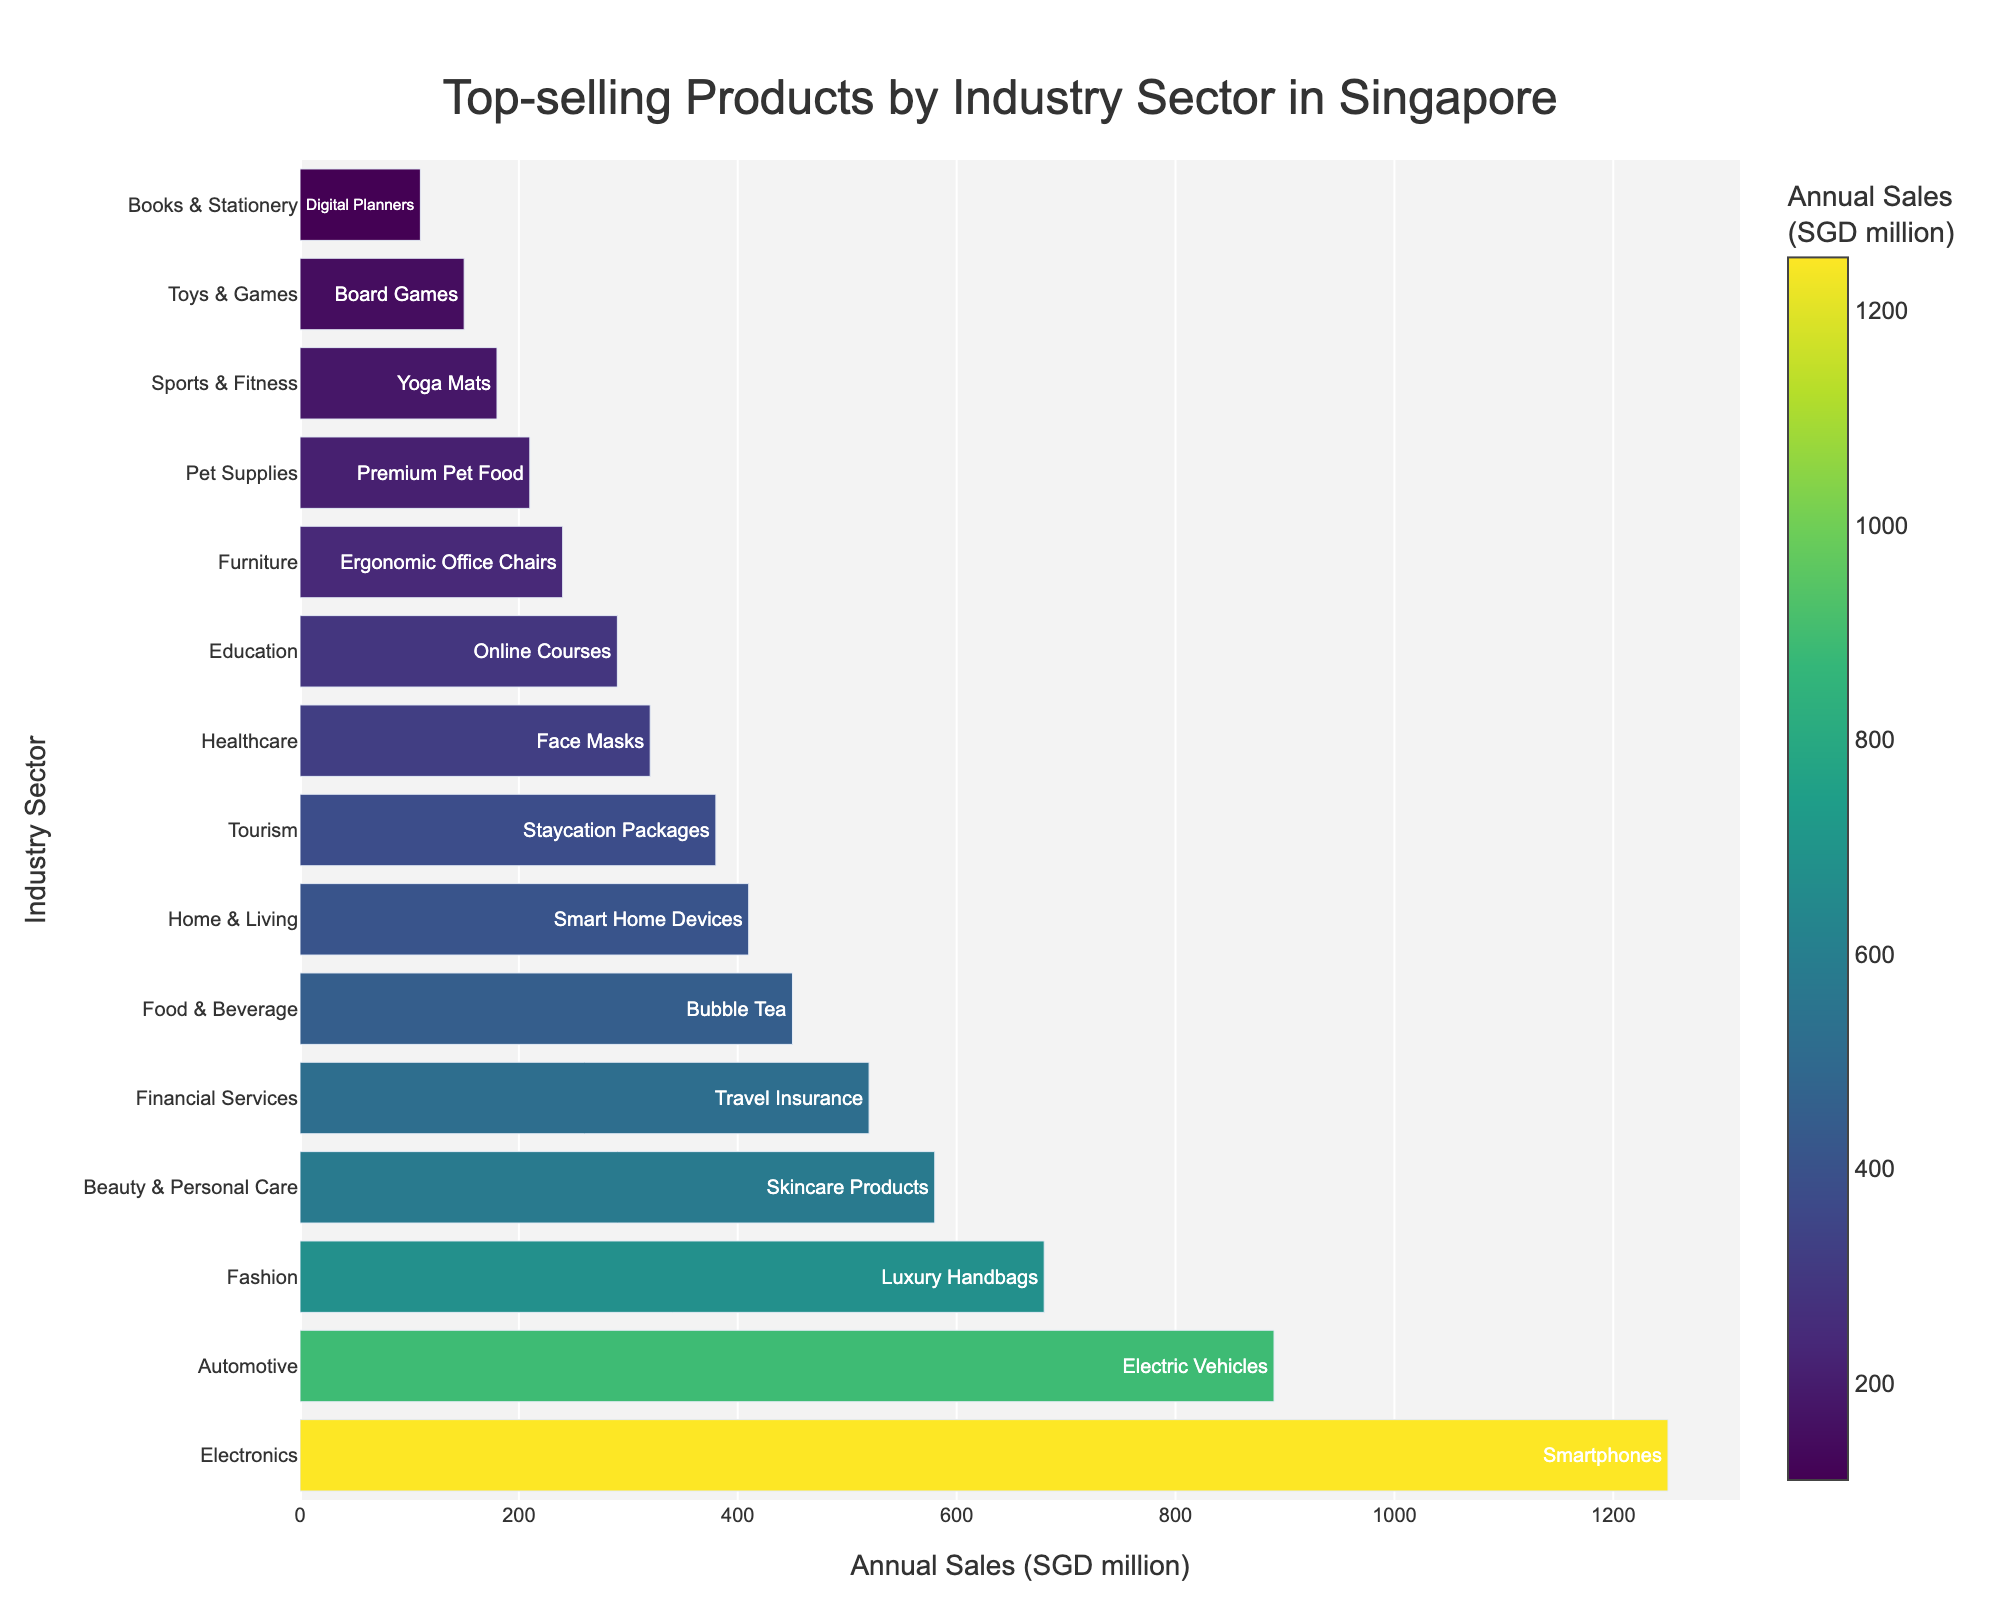What is the industry sector with the highest annual sales? The industry sector with the highest annual sales can be identified by looking for the tallest bar on the plot. The tallest bar belongs to the Electronics sector.
Answer: Electronics Which industry sector has the lowest annual sales, and what is its top-selling product? To find the industry sector with the lowest annual sales, look for the shortest bar in the plot. The shortest bar belongs to the Books & Stationery sector, and its top-selling product is Digital Planners.
Answer: Books & Stationery Which two industry sectors have annual sales of over 1,000 million SGD? To find industry sectors with annual sales over 1,000 million SGD, identify the bars that extend past the 1,000 million mark on the x-axis. The two sectors are Electronics and Automotive.
Answer: Electronics, Automotive What is the difference in annual sales between the Healthcare and Tourism sectors? To find the difference in annual sales, locate the positions of the bars for Healthcare and Tourism. Healthcare has 320 million SGD, and Tourism has 380 million SGD. The difference is 380 - 320 = 60 million SGD.
Answer: 60 million SGD What are the top-selling products for the top 3 industry sectors? To determine the top 3 industry sectors, look at the three tallest bars in the plot. They are Electronics (Smartphones), Automotive (Electric Vehicles), and Fashion (Luxury Handbags).
Answer: Smartphones, Electric Vehicles, Luxury Handbags Which industry sector has annual sales closest to 300 million SGD? To find the industry sector with annual sales closest to 300 million SGD, locate the bars near the 300 million mark. The Healthcare sector has annual sales of 320 million SGD, which is closest to 300 million.
Answer: Healthcare What is the combined annual sales of the Financial Services and Tourism sectors? To find the combined annual sales, add the values of the bars for Financial Services (520 million SGD) and Tourism (380 million SGD). The combined total is 520 + 380 = 900 million SGD.
Answer: 900 million SGD How does the annual sales of Smart Home Devices compare to Face Masks? To compare the annual sales, observe the bars for the Home & Living sector (Smart Home Devices) and Healthcare sector (Face Masks). Smart Home Devices have 410 million SGD, while Face Masks have 320 million SGD. Smart Home Devices have higher sales.
Answer: Smart Home Devices have higher sales What color represents the Skincare Products bar on the color scale? Identify the color of the bar for the Beauty & Personal Care sector, which sells Skincare Products. The color scale ranges from light to dark green. The Skincare Products bar is represented by a medium shade of green.
Answer: Medium shade of green What is the annual sales gap between the top-selling product of the Fashion sector and the top-selling product of the Food & Beverage sector? First, identify the annual sales for the Fashion sector (680 million SGD) and the Food & Beverage sector (450 million SGD). Calculate the gap: 680 - 450 = 230 million SGD.
Answer: 230 million SGD 